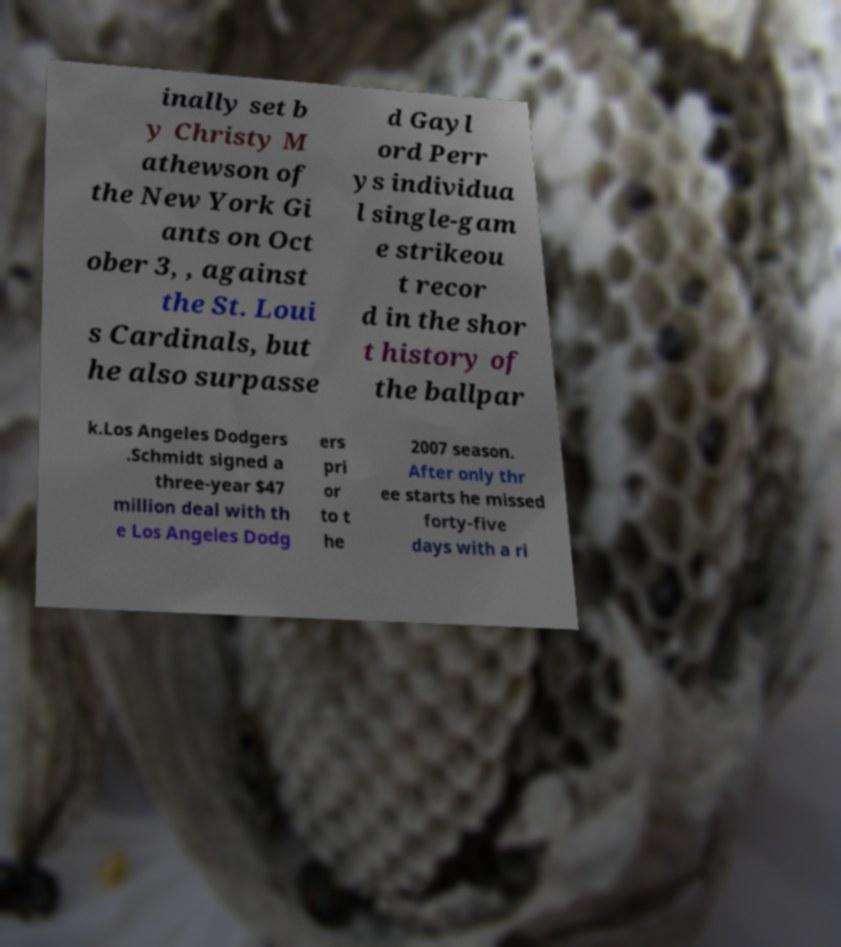Could you extract and type out the text from this image? inally set b y Christy M athewson of the New York Gi ants on Oct ober 3, , against the St. Loui s Cardinals, but he also surpasse d Gayl ord Perr ys individua l single-gam e strikeou t recor d in the shor t history of the ballpar k.Los Angeles Dodgers .Schmidt signed a three-year $47 million deal with th e Los Angeles Dodg ers pri or to t he 2007 season. After only thr ee starts he missed forty-five days with a ri 